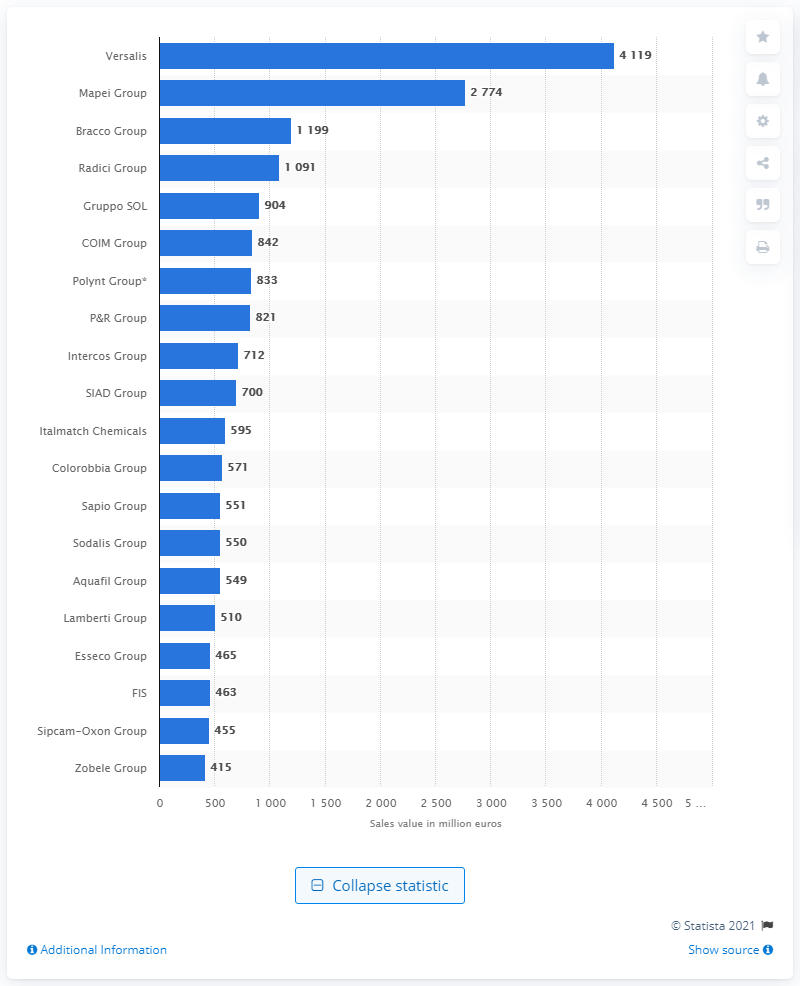Draw attention to some important aspects in this diagram. Versalis was the largest Italian manufacturer of chemical products with a sales value of over 2.8 billion euros, followed by the Mapei Group, which had the second-highest sales value among Italian chemical product manufacturers. Versalis' worldwide sales value in 2020 was €4,119 million. 